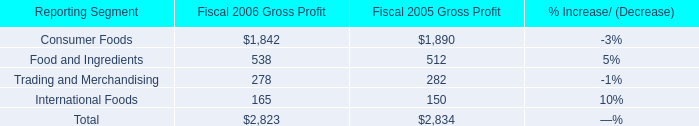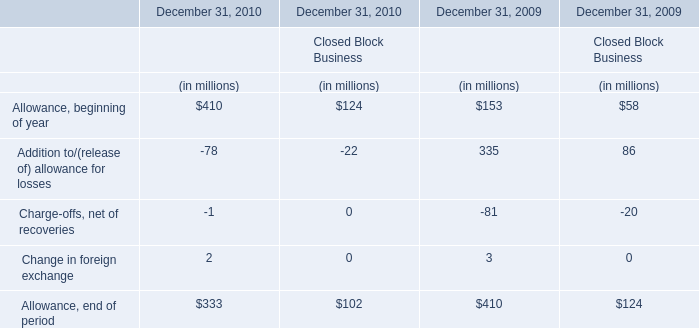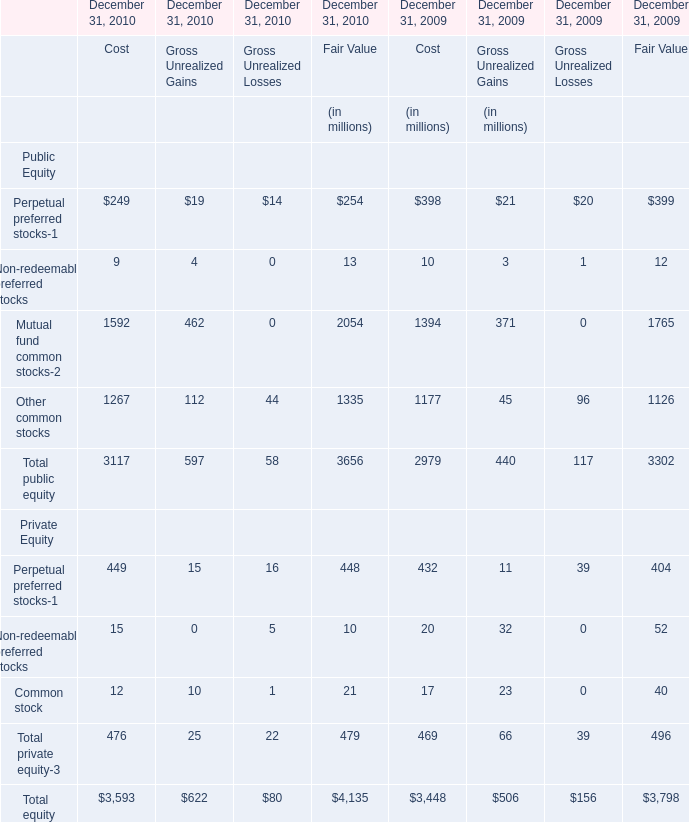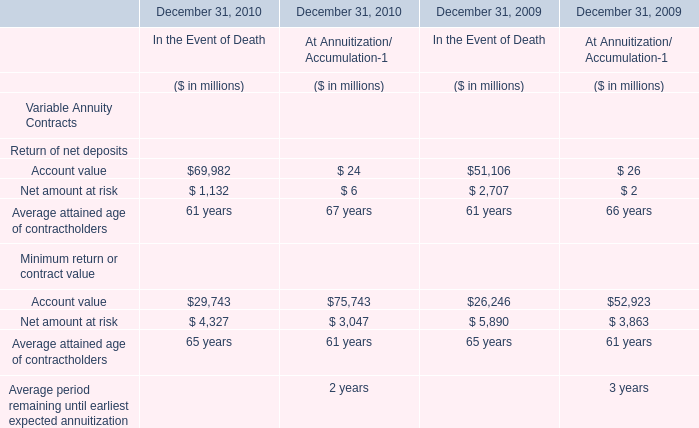Which year is Change in foreign exchange for financial services businesses the highest? 
Answer: 2009. 